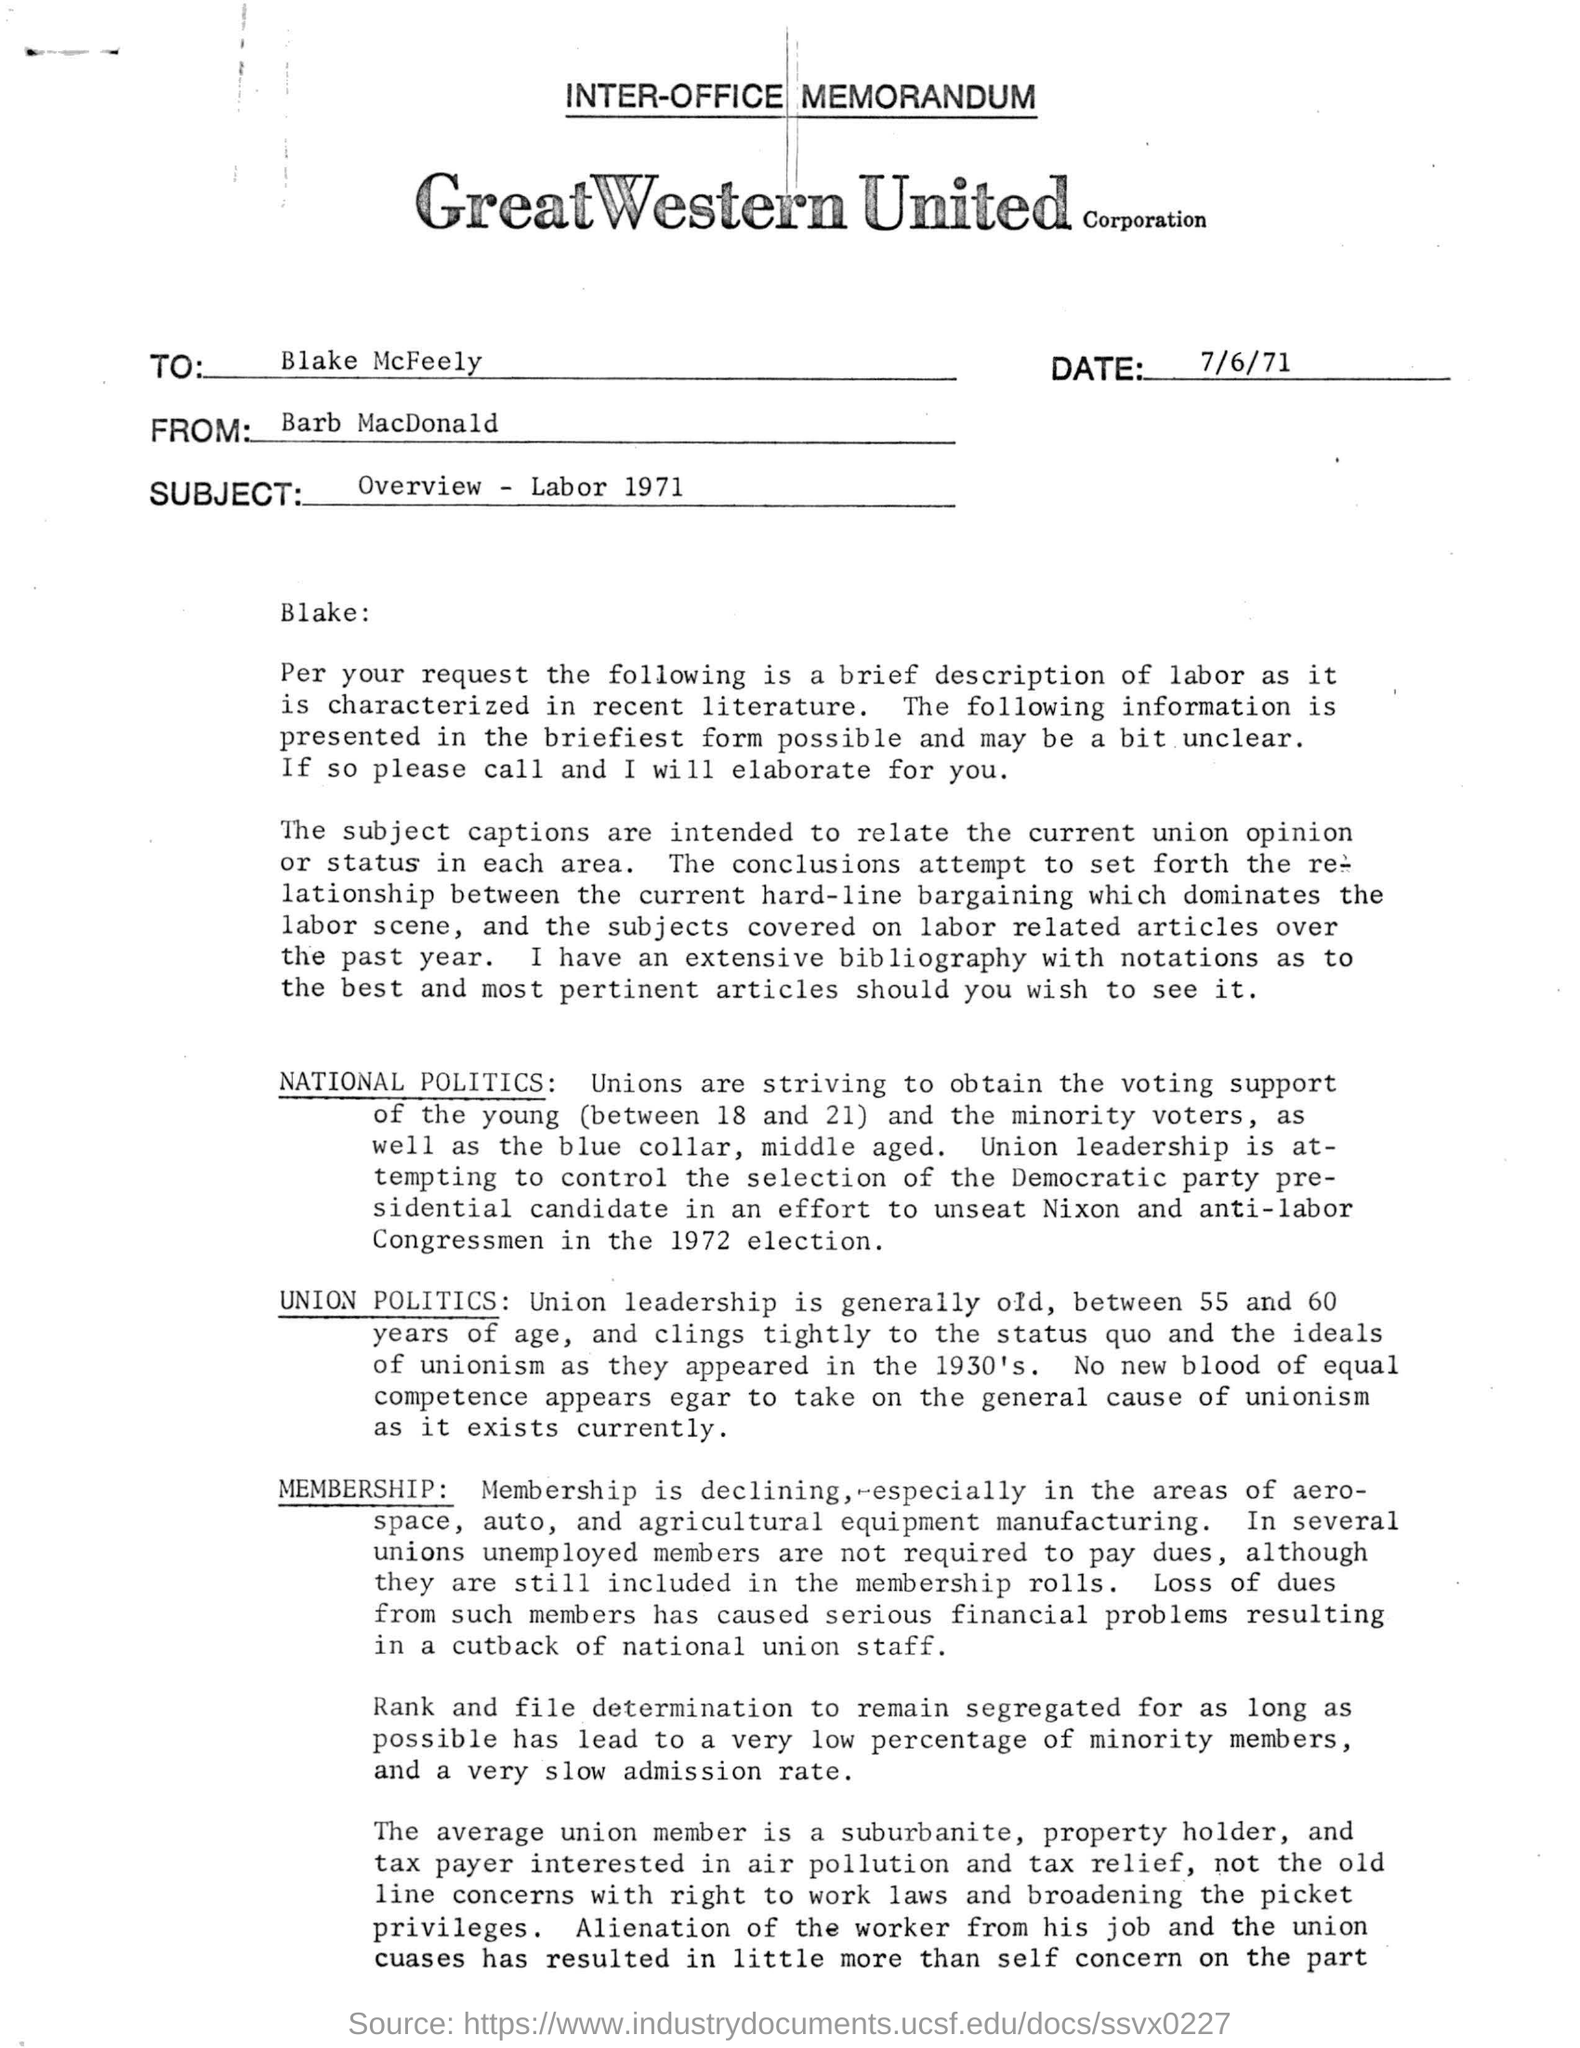Indicate a few pertinent items in this graphic. The memorandum mentions a date, which is 7/6/71. The letterhead mentions Great Western United Corporation. The memorandum is addressed to Blake McFeely. The union leadership is responsible for attempting to control the election of the Democratic party's presidential candidate. Union leadership must fall between the ages of 55 and 60, as stated. 